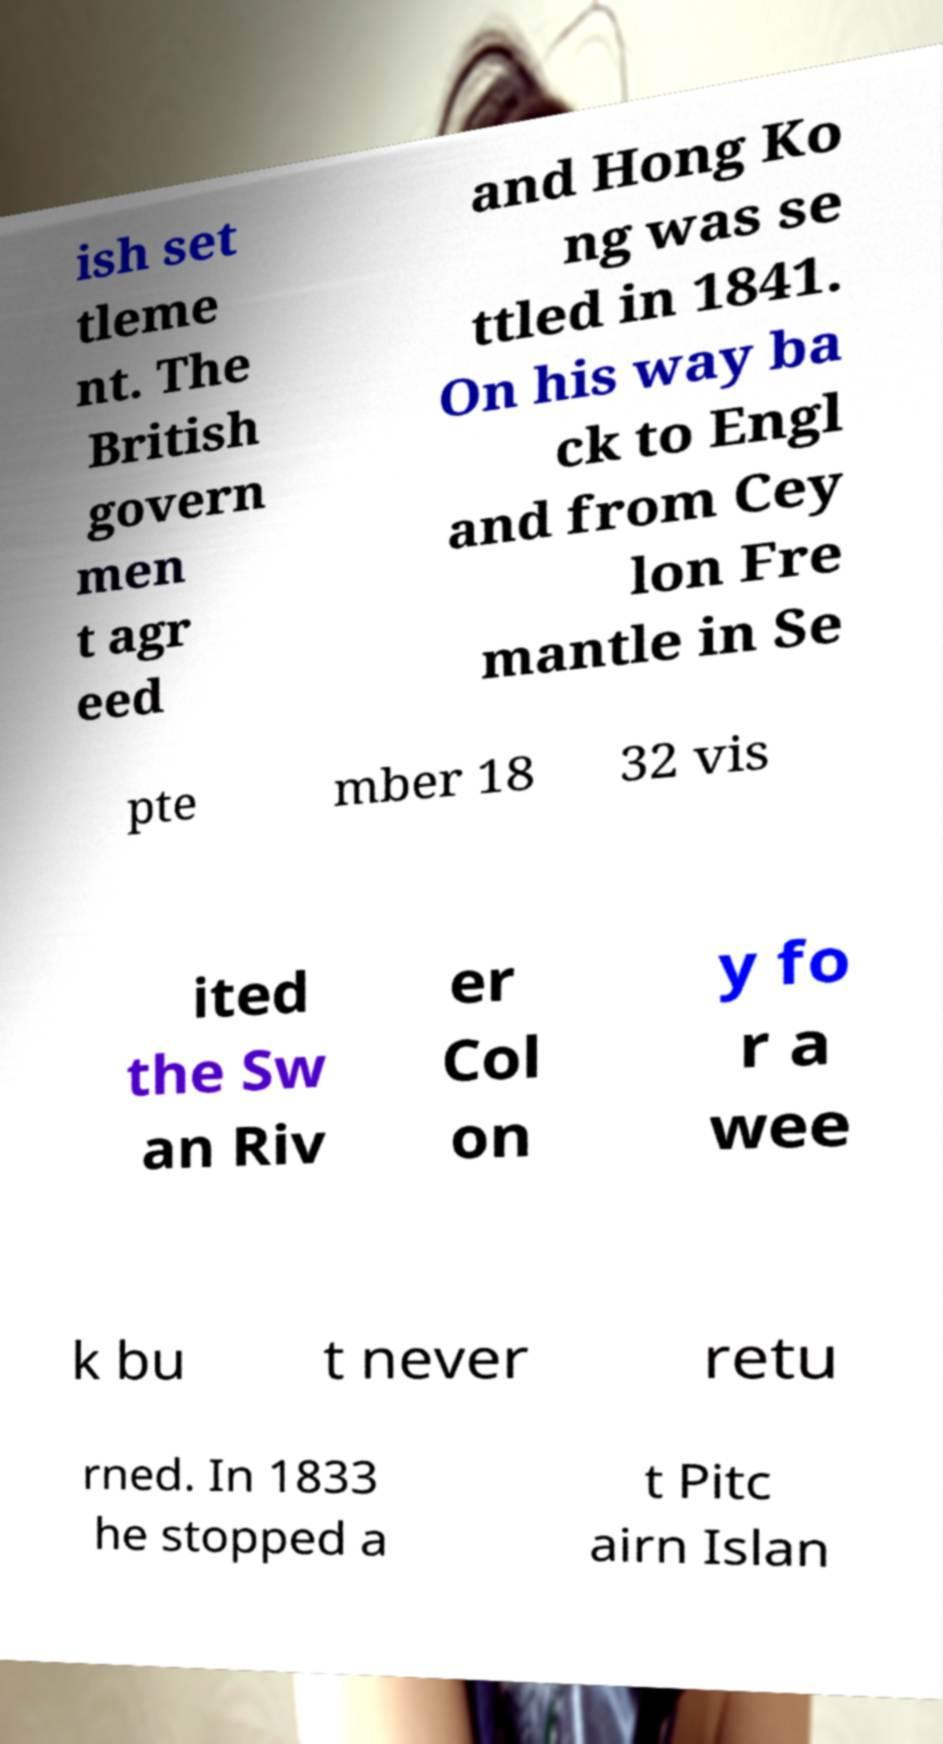Please identify and transcribe the text found in this image. ish set tleme nt. The British govern men t agr eed and Hong Ko ng was se ttled in 1841. On his way ba ck to Engl and from Cey lon Fre mantle in Se pte mber 18 32 vis ited the Sw an Riv er Col on y fo r a wee k bu t never retu rned. In 1833 he stopped a t Pitc airn Islan 